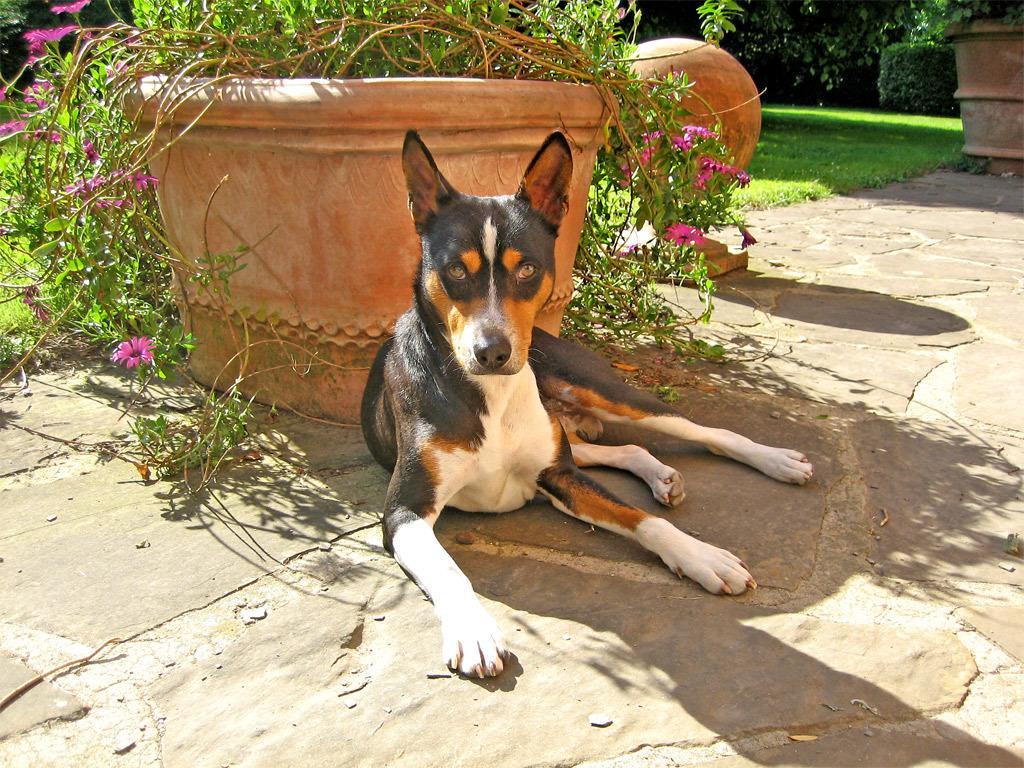Describe this image in one or two sentences. In this image in the center there is one dog and in the background there is a flower pot, plant and some grass at the bottom there is a walkway. On the top of the right corner there is another flower pot, plants and grass. 